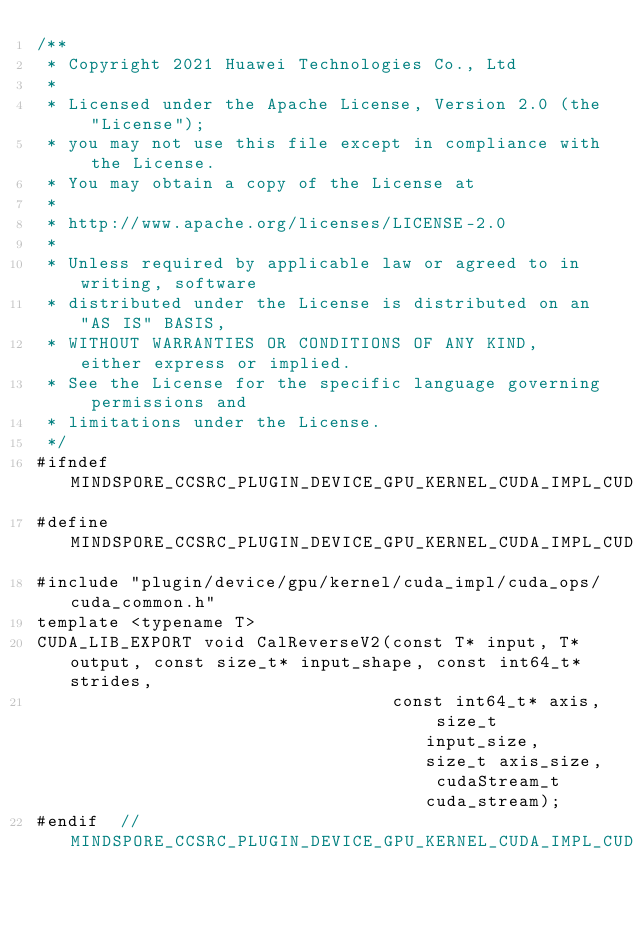Convert code to text. <code><loc_0><loc_0><loc_500><loc_500><_Cuda_>/**
 * Copyright 2021 Huawei Technologies Co., Ltd
 *
 * Licensed under the Apache License, Version 2.0 (the "License");
 * you may not use this file except in compliance with the License.
 * You may obtain a copy of the License at
 *
 * http://www.apache.org/licenses/LICENSE-2.0
 *
 * Unless required by applicable law or agreed to in writing, software
 * distributed under the License is distributed on an "AS IS" BASIS,
 * WITHOUT WARRANTIES OR CONDITIONS OF ANY KIND, either express or implied.
 * See the License for the specific language governing permissions and
 * limitations under the License.
 */
#ifndef MINDSPORE_CCSRC_PLUGIN_DEVICE_GPU_KERNEL_CUDA_IMPL_CUDA_OPS_REVERSE_V2_IMPL_CUH_
#define MINDSPORE_CCSRC_PLUGIN_DEVICE_GPU_KERNEL_CUDA_IMPL_CUDA_OPS_REVERSE_V2_IMPL_CUH_
#include "plugin/device/gpu/kernel/cuda_impl/cuda_ops/cuda_common.h"
template <typename T>
CUDA_LIB_EXPORT void CalReverseV2(const T* input, T* output, const size_t* input_shape, const int64_t* strides,
                                  const int64_t* axis, size_t input_size, size_t axis_size, cudaStream_t cuda_stream);
#endif  // MINDSPORE_CCSRC_PLUGIN_DEVICE_GPU_KERNEL_CUDA_IMPL_CUDA_OPS_REVERSE_V2_IMPL_CUH_
</code> 